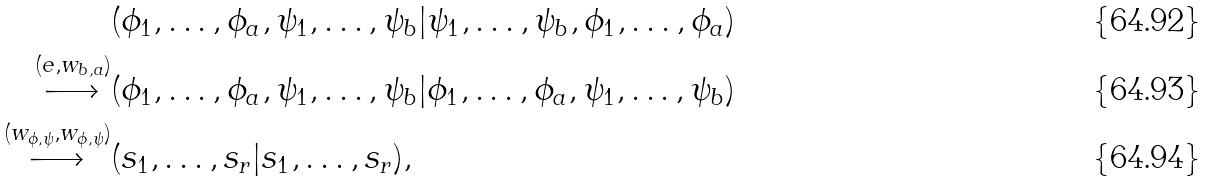<formula> <loc_0><loc_0><loc_500><loc_500>& ( \phi _ { 1 } , \dots , \phi _ { a } , \psi _ { 1 } , \dots , \psi _ { b } | \psi _ { 1 } , \dots , \psi _ { b } , \phi _ { 1 } , \dots , \phi _ { a } ) \\ \stackrel { ( e , w _ { b , a } ) } { \longrightarrow } & ( \phi _ { 1 } , \dots , \phi _ { a } , \psi _ { 1 } , \dots , \psi _ { b } | \phi _ { 1 } , \dots , \phi _ { a } , \psi _ { 1 } , \dots , \psi _ { b } ) \\ \stackrel { ( w _ { \phi , \psi } , w _ { \phi , \psi } ) } { \longrightarrow } & ( s _ { 1 } , \dots , s _ { r } | s _ { 1 } , \dots , s _ { r } ) ,</formula> 